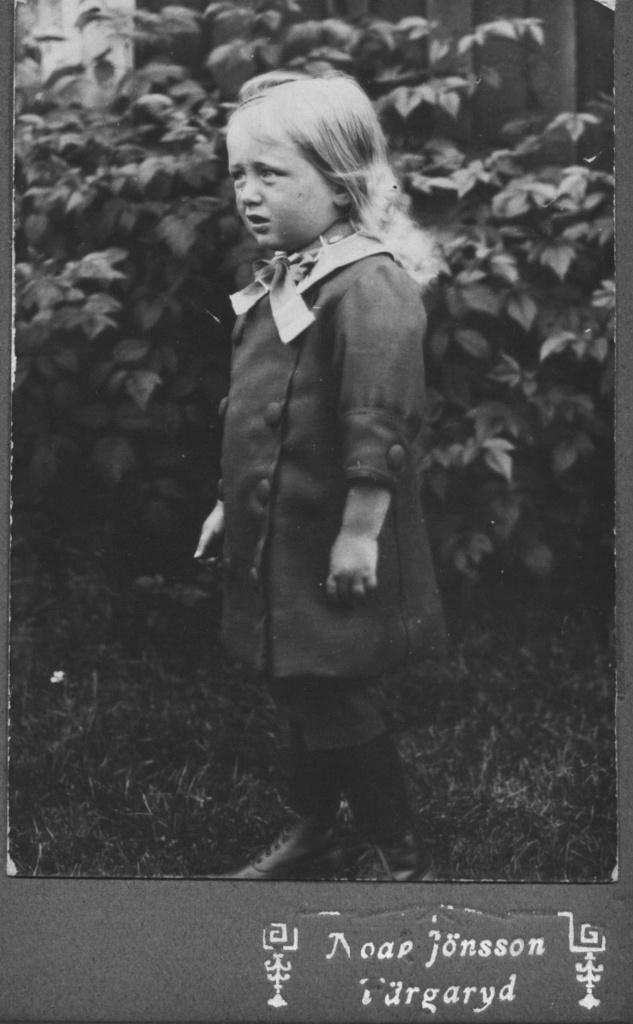Could you give a brief overview of what you see in this image? It is a black and white image, in this a girl is standing, she wore dress behind her there are plants. 